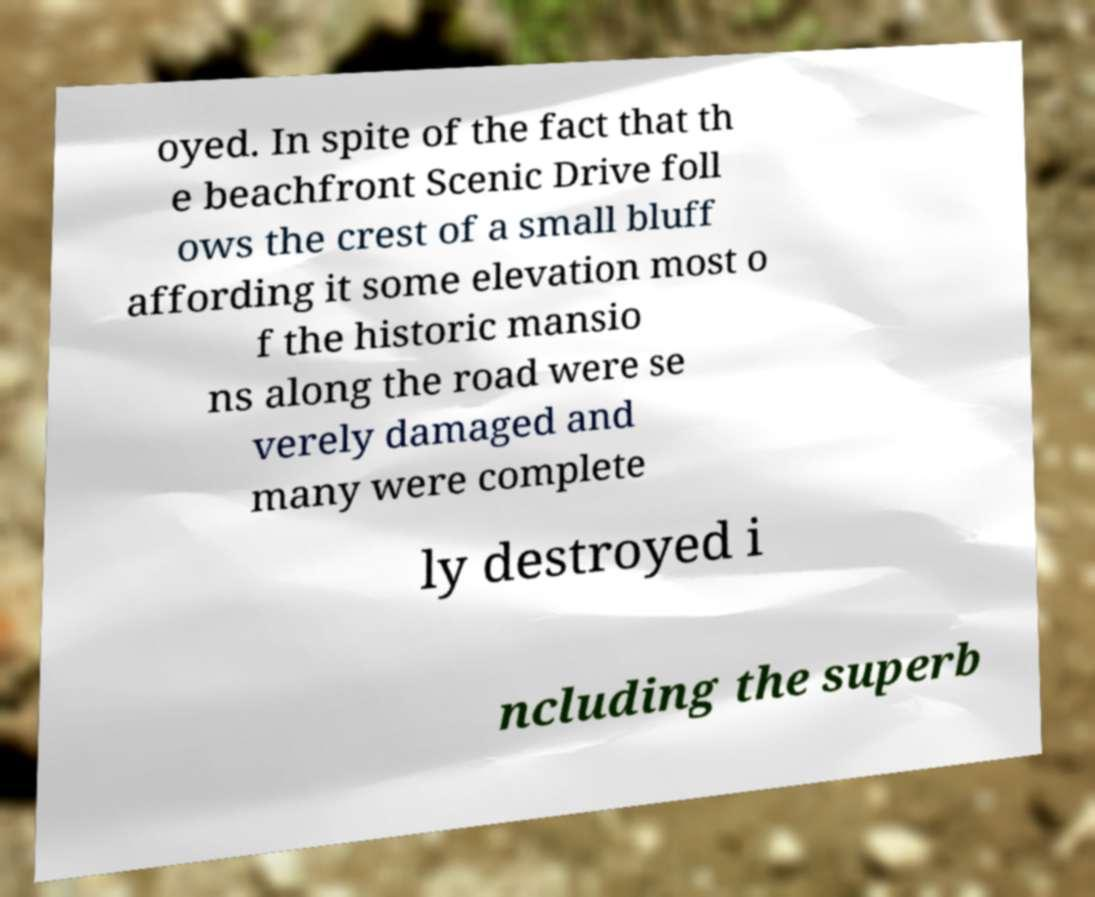I need the written content from this picture converted into text. Can you do that? oyed. In spite of the fact that th e beachfront Scenic Drive foll ows the crest of a small bluff affording it some elevation most o f the historic mansio ns along the road were se verely damaged and many were complete ly destroyed i ncluding the superb 